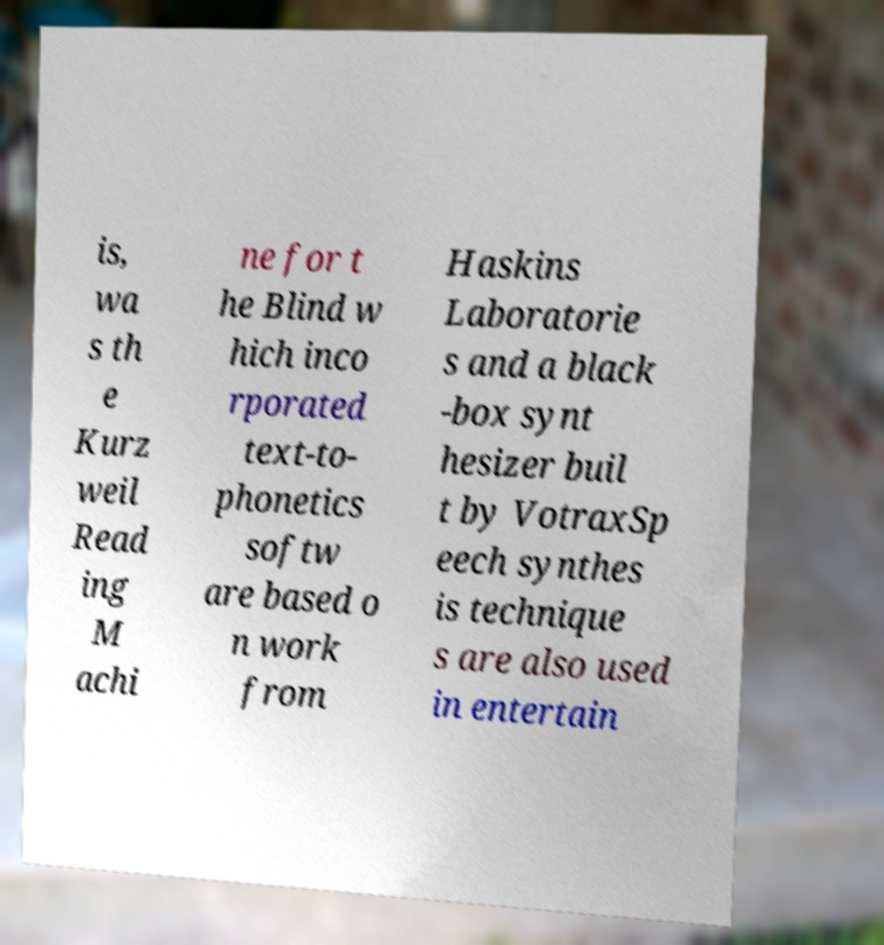I need the written content from this picture converted into text. Can you do that? is, wa s th e Kurz weil Read ing M achi ne for t he Blind w hich inco rporated text-to- phonetics softw are based o n work from Haskins Laboratorie s and a black -box synt hesizer buil t by VotraxSp eech synthes is technique s are also used in entertain 